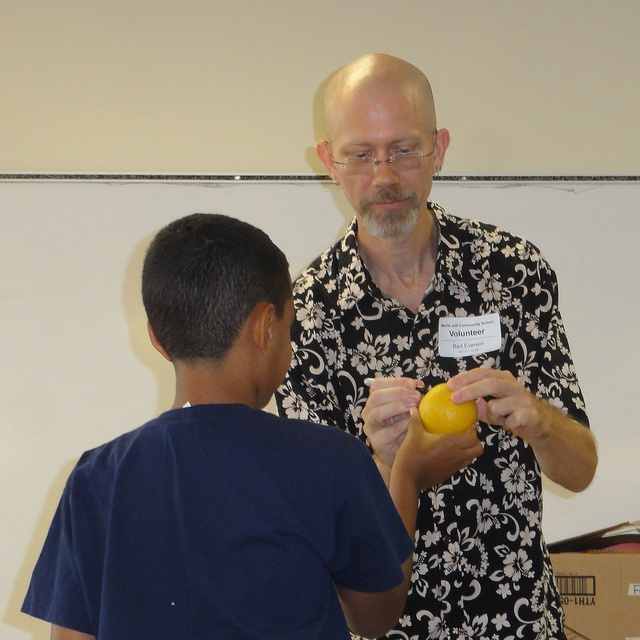Describe the objects in this image and their specific colors. I can see people in tan, black, gray, and darkgray tones, people in tan, black, navy, and maroon tones, and orange in tan, orange, olive, and brown tones in this image. 